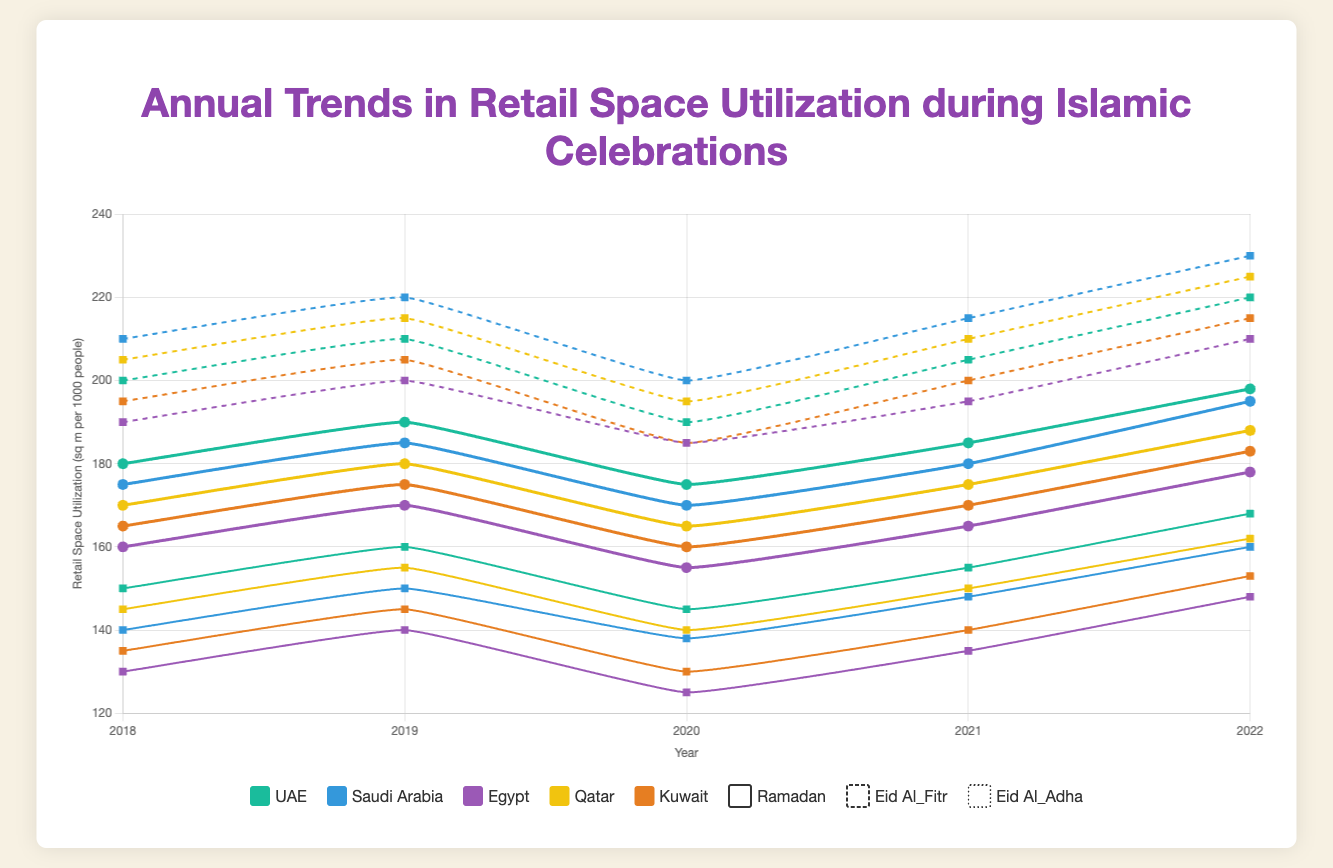Which country showed the highest retail space utilization during Eid Al-Fitr in 2022? By looking at the 2022 data for Eid Al-Fitr across all countries, we observe that Saudi Arabia has a value of 230, which is the highest.
Answer: Saudi Arabia How did Egypt's retail space utilization during Ramadan change from 2018 to 2022? From the plot, we follow the trend line for Ramadan utilization in Egypt across the years: 130 in 2018, 140 in 2019, 125 in 2020, 135 in 2021, and 148 in 2022. The values show an increase from 130 to 148 over these years.
Answer: Increased Which celebration generally has the highest retail space utilization in Qatar? By comparing the lines for Ramadan, Eid Al-Fitr, and Eid Al-Adha for Qatar, we see that Eid Al-Fitr consistently shows the highest values over all years.
Answer: Eid Al-Fitr In which year did the UAE experience the greatest retail space utilization during Eid Al-Adha? Following the trend line for Eid Al-Adha in UAE, the highest data point appears in 2022 with a value of 198.
Answer: 2022 Compare the trends in retail space utilization for Eid Al-Fitr between UAE and Kuwait. Noticing the trends for Eid Al-Fitr: UAE's values: 200, 210, 190, 205, 220; Kuwait's values: 195, 205, 185, 200, 215. Both countries show a general increase over the years, but UAE's values are consistently a bit higher.
Answer: UAE is higher What is the average retail space utilization for Ramadan in Saudi Arabia across the given years? Adding values for Saudi Arabia during Ramadan: 140 + 150 + 138 + 148 + 160 = 736. Dividing by 5 (number of years): 736 / 5 = 147.2.
Answer: 147.2 How does the retail space utilization during Eid Al-Adha in Egypt in 2021 compare to that in Qatar in the same year? Referencing the plot for 2021, Egypt's value for Eid Al-Adha is 165, and Qatar's value is 175. Thus, Egypt's value is lower than Qatar's.
Answer: Lower Which country shows the least variation in retail space utilization during Ramadan over the years? By observing the trend lines, UAE's values: 150, 160, 145, 155, 168; Show the least fluctuation, indicating the least variation compared to other countries.
Answer: UAE What's the difference in retail space utilization for Eid Al-Fitr between 2018 and 2020 in Qatar? Observing the values for Eid Al-Fitr in Qatar: 205 in 2018 and 195 in 2020. The difference is 205 - 195 = 10.
Answer: 10 Calculate the combined retail space utilization for Eid Al-Adha in Kuwait over the years. Summing up the values for Kuwait during Eid Al-Adha: 165 + 175 + 160 + 170 + 183 = 853.
Answer: 853 